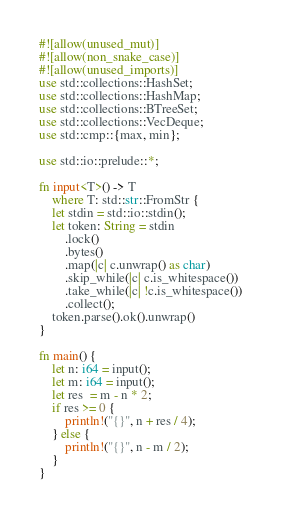<code> <loc_0><loc_0><loc_500><loc_500><_Rust_>#![allow(unused_mut)]
#![allow(non_snake_case)]
#![allow(unused_imports)]
use std::collections::HashSet;
use std::collections::HashMap;
use std::collections::BTreeSet;
use std::collections::VecDeque;
use std::cmp::{max, min};

use std::io::prelude::*;

fn input<T>() -> T
    where T: std::str::FromStr {
    let stdin = std::io::stdin();
    let token: String = stdin
        .lock()
        .bytes()
        .map(|c| c.unwrap() as char)
        .skip_while(|c| c.is_whitespace())
        .take_while(|c| !c.is_whitespace())
        .collect();
    token.parse().ok().unwrap()
}

fn main() {
    let n: i64 = input();
    let m: i64 = input();
    let res  = m - n * 2;
    if res >= 0 {
        println!("{}", n + res / 4);
    } else {
        println!("{}", n - m / 2);
    }
}</code> 